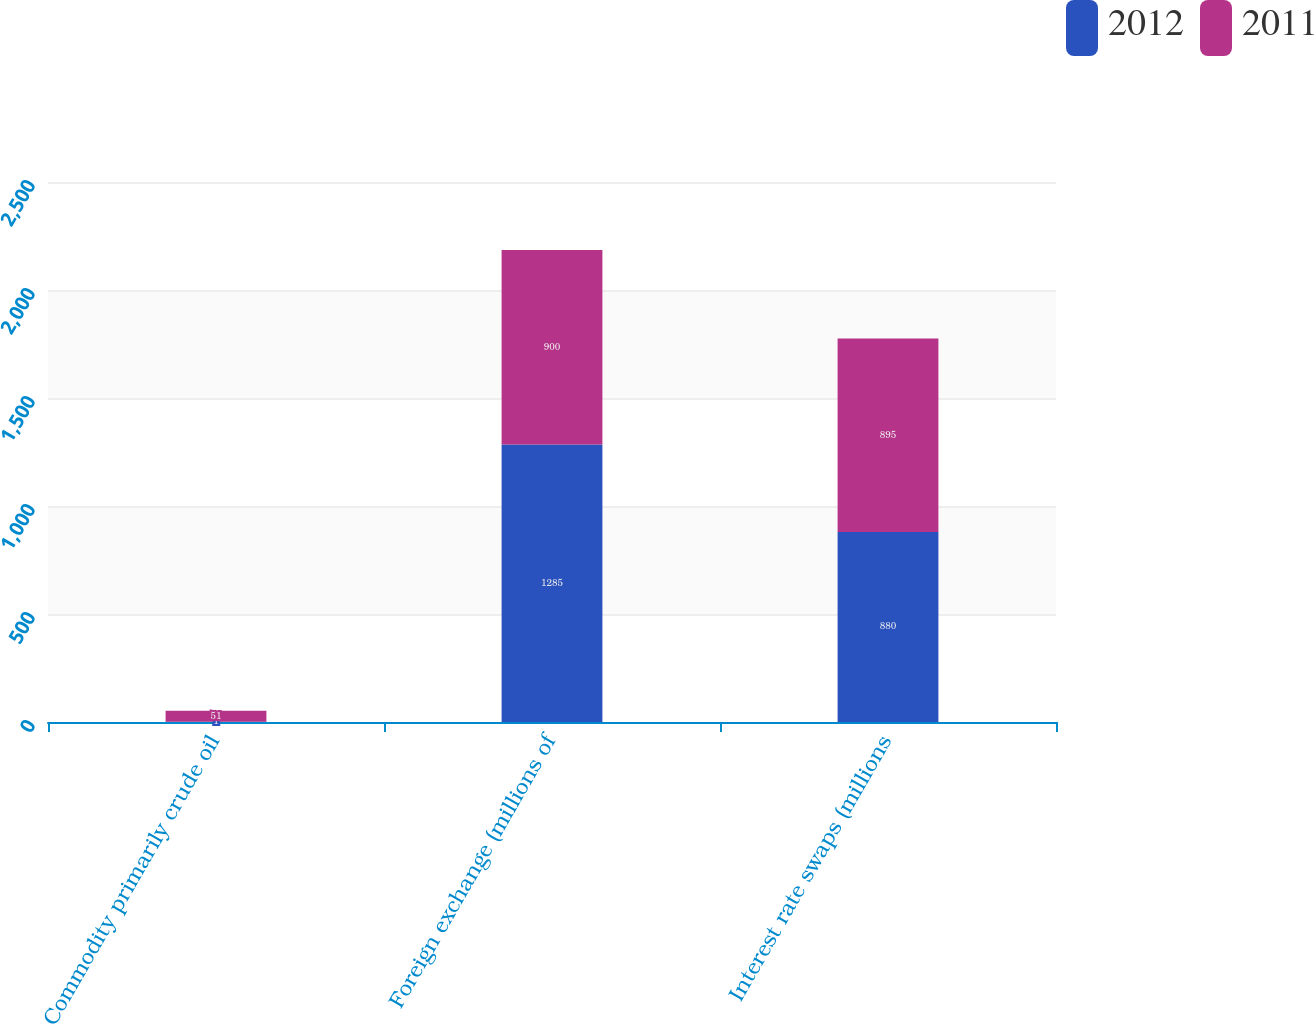Convert chart to OTSL. <chart><loc_0><loc_0><loc_500><loc_500><stacked_bar_chart><ecel><fcel>Commodity primarily crude oil<fcel>Foreign exchange (millions of<fcel>Interest rate swaps (millions<nl><fcel>2012<fcel>1<fcel>1285<fcel>880<nl><fcel>2011<fcel>51<fcel>900<fcel>895<nl></chart> 